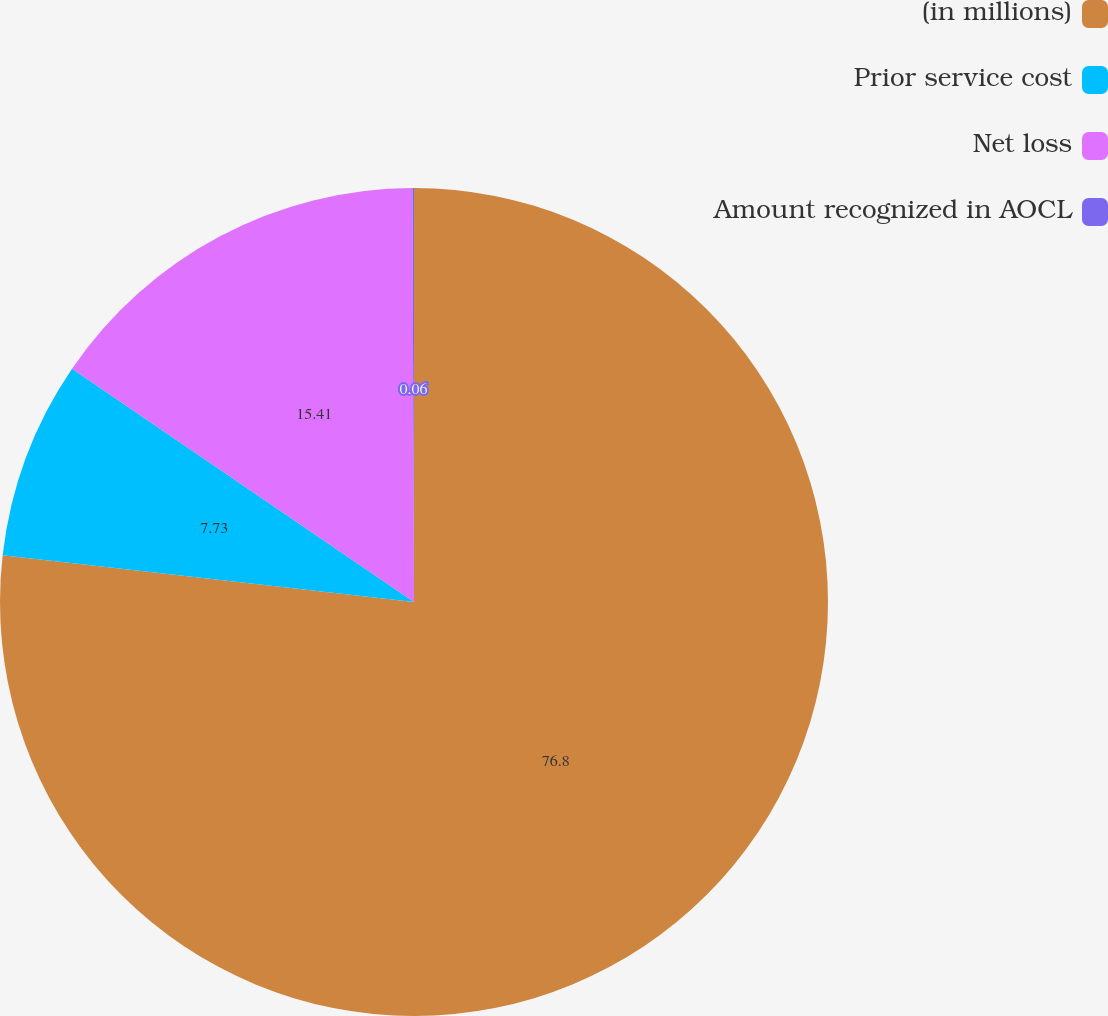Convert chart to OTSL. <chart><loc_0><loc_0><loc_500><loc_500><pie_chart><fcel>(in millions)<fcel>Prior service cost<fcel>Net loss<fcel>Amount recognized in AOCL<nl><fcel>76.8%<fcel>7.73%<fcel>15.41%<fcel>0.06%<nl></chart> 